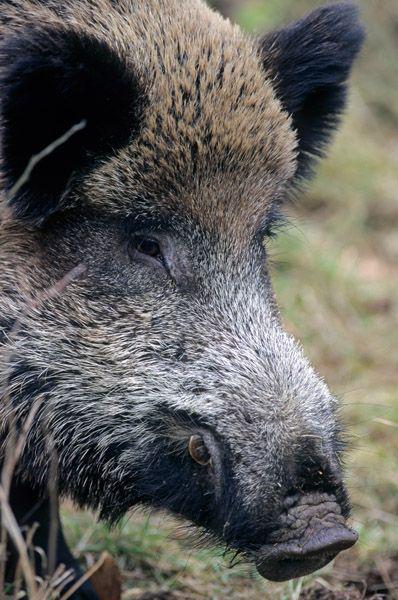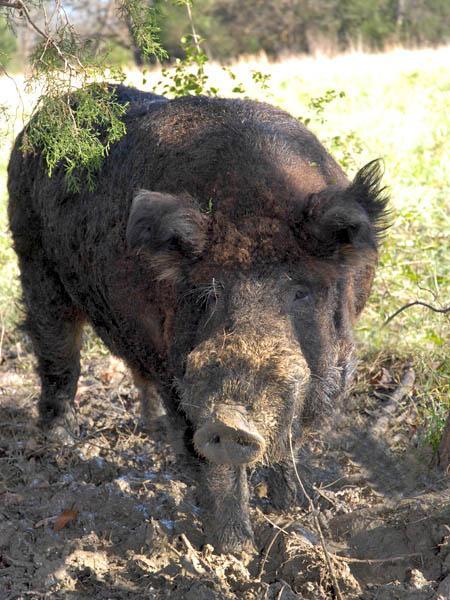The first image is the image on the left, the second image is the image on the right. Given the left and right images, does the statement "One image shows a forward-turned wild pig without visible tusks, standing on elevated ground and looking downward." hold true? Answer yes or no. No. The first image is the image on the left, the second image is the image on the right. For the images displayed, is the sentence "In at least one image there is a black eared boar with there body facing right while it's snout is facing forward left." factually correct? Answer yes or no. Yes. 